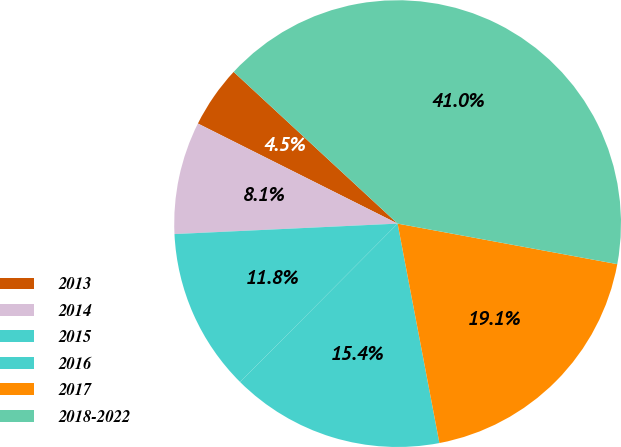Convert chart to OTSL. <chart><loc_0><loc_0><loc_500><loc_500><pie_chart><fcel>2013<fcel>2014<fcel>2015<fcel>2016<fcel>2017<fcel>2018-2022<nl><fcel>4.49%<fcel>8.14%<fcel>11.8%<fcel>15.45%<fcel>19.1%<fcel>41.02%<nl></chart> 